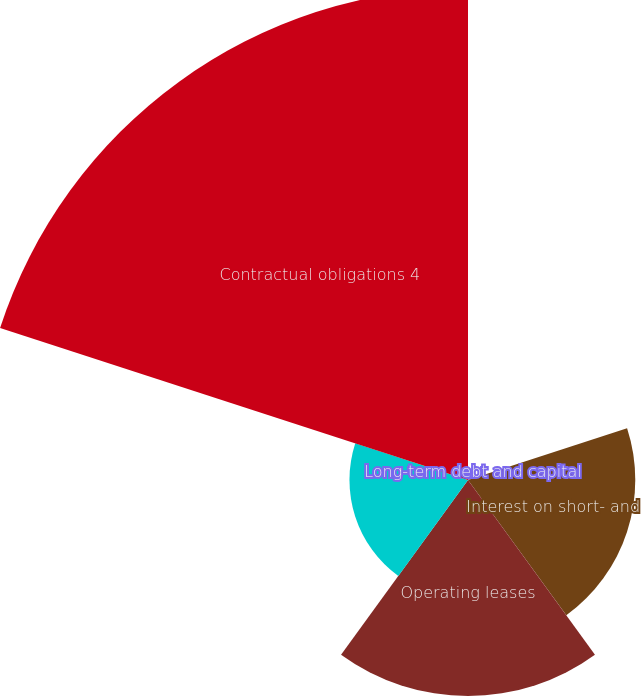Convert chart. <chart><loc_0><loc_0><loc_500><loc_500><pie_chart><fcel>Long-term debt and capital<fcel>Interest on short- and<fcel>Operating leases<fcel>Purchase obligations 3<fcel>Contractual obligations 4<nl><fcel>0.47%<fcel>16.75%<fcel>21.63%<fcel>11.87%<fcel>49.27%<nl></chart> 